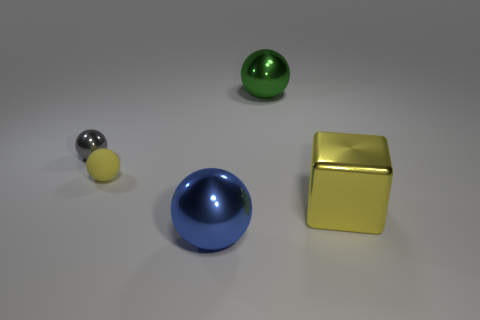There is a object that is in front of the yellow block; is its shape the same as the small thing left of the tiny matte sphere? Yes, the object in front of the yellow block shares the same spherical shape as the smaller object located to the left of the tiny matte sphere. 